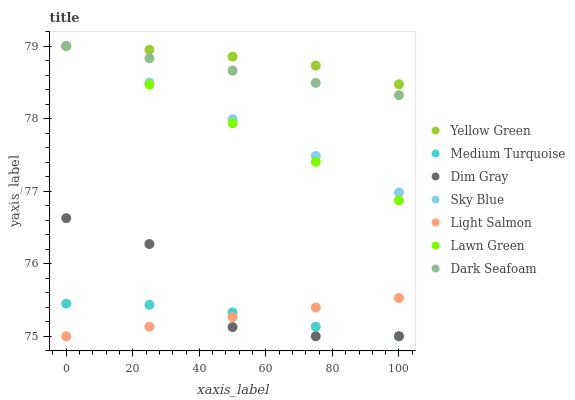Does Light Salmon have the minimum area under the curve?
Answer yes or no. Yes. Does Yellow Green have the maximum area under the curve?
Answer yes or no. Yes. Does Dim Gray have the minimum area under the curve?
Answer yes or no. No. Does Dim Gray have the maximum area under the curve?
Answer yes or no. No. Is Sky Blue the smoothest?
Answer yes or no. Yes. Is Dim Gray the roughest?
Answer yes or no. Yes. Is Light Salmon the smoothest?
Answer yes or no. No. Is Light Salmon the roughest?
Answer yes or no. No. Does Light Salmon have the lowest value?
Answer yes or no. Yes. Does Yellow Green have the lowest value?
Answer yes or no. No. Does Sky Blue have the highest value?
Answer yes or no. Yes. Does Light Salmon have the highest value?
Answer yes or no. No. Is Dim Gray less than Sky Blue?
Answer yes or no. Yes. Is Dark Seafoam greater than Light Salmon?
Answer yes or no. Yes. Does Light Salmon intersect Dim Gray?
Answer yes or no. Yes. Is Light Salmon less than Dim Gray?
Answer yes or no. No. Is Light Salmon greater than Dim Gray?
Answer yes or no. No. Does Dim Gray intersect Sky Blue?
Answer yes or no. No. 